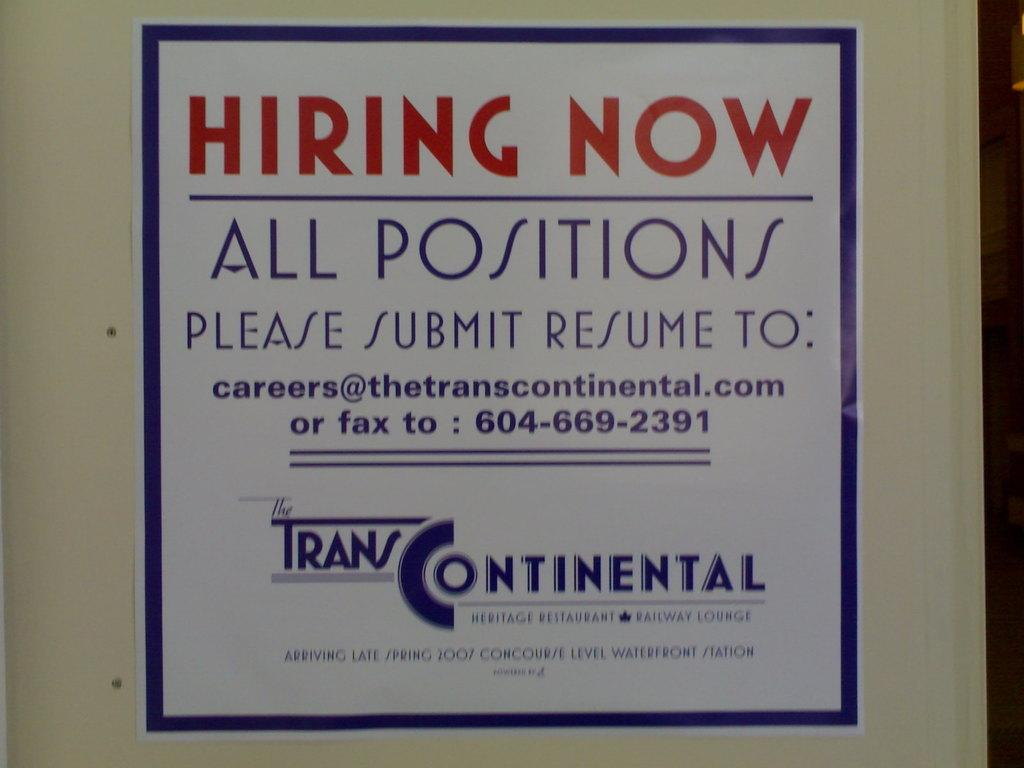<image>
Relay a brief, clear account of the picture shown. An advertisement for open positions at Trans Continental. 